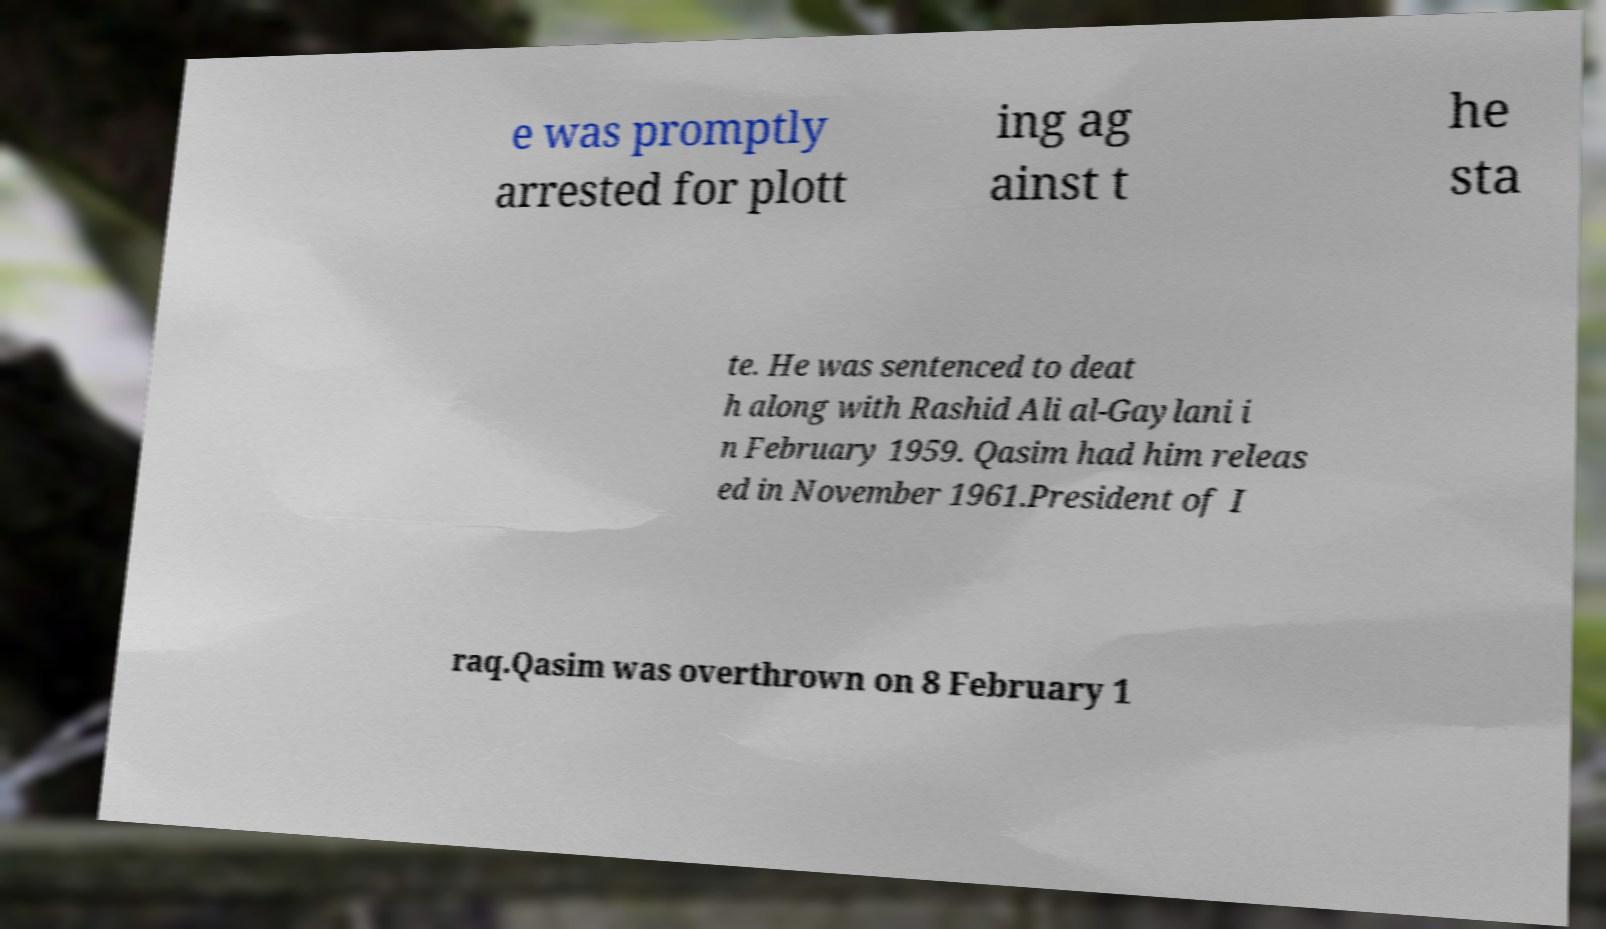Could you extract and type out the text from this image? e was promptly arrested for plott ing ag ainst t he sta te. He was sentenced to deat h along with Rashid Ali al-Gaylani i n February 1959. Qasim had him releas ed in November 1961.President of I raq.Qasim was overthrown on 8 February 1 